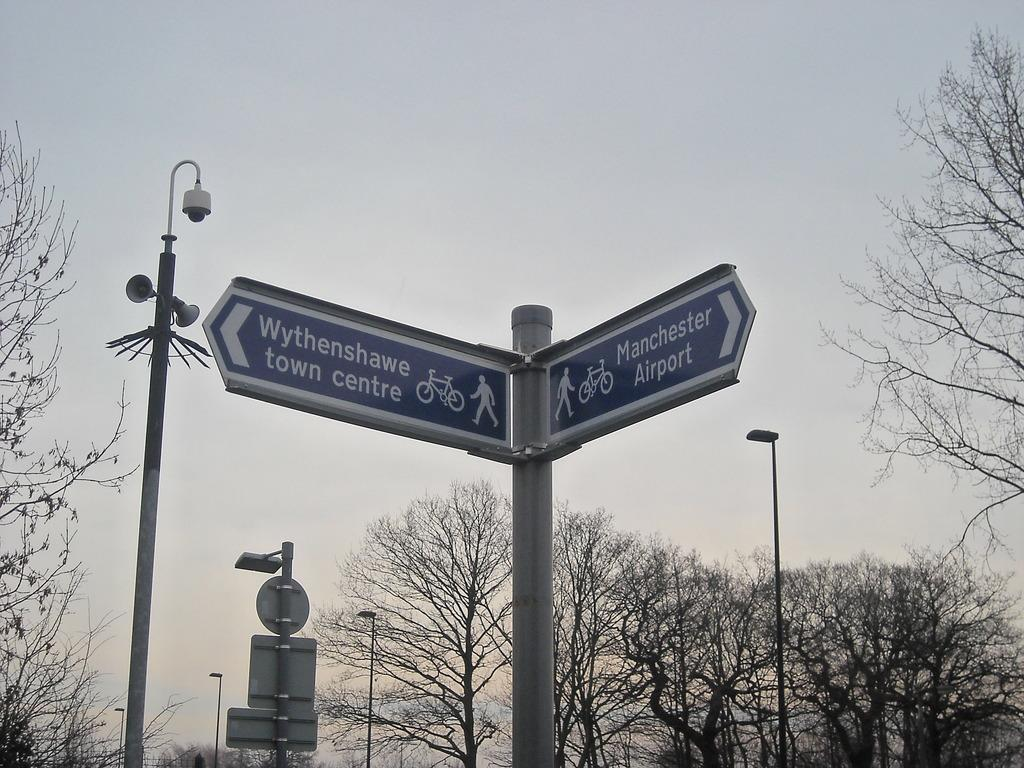What type of vegetation is present in the image? There are trees in the image. What structures are visible in the image? There are light poles, sign boards, and boards in the image. Are there any audio devices in the image? Yes, there are speakers attached to the pole in the image. What is visible at the top of the image? The sky is visible at the top of the image. Can you see the inventor's hand holding the invention in the image? There is no invention or hand present in the image. What color is the inventor's nose in the image? There is no inventor or nose present in the image. 